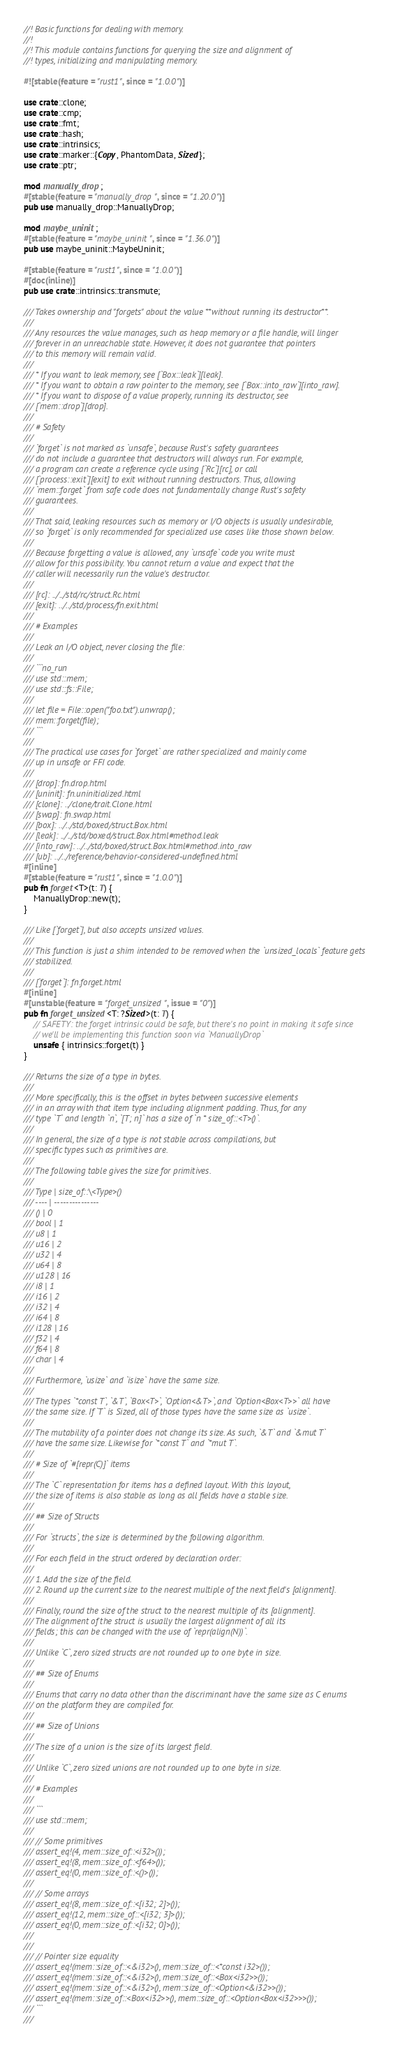Convert code to text. <code><loc_0><loc_0><loc_500><loc_500><_Rust_>//! Basic functions for dealing with memory.
//!
//! This module contains functions for querying the size and alignment of
//! types, initializing and manipulating memory.

#![stable(feature = "rust1", since = "1.0.0")]

use crate::clone;
use crate::cmp;
use crate::fmt;
use crate::hash;
use crate::intrinsics;
use crate::marker::{Copy, PhantomData, Sized};
use crate::ptr;

mod manually_drop;
#[stable(feature = "manually_drop", since = "1.20.0")]
pub use manually_drop::ManuallyDrop;

mod maybe_uninit;
#[stable(feature = "maybe_uninit", since = "1.36.0")]
pub use maybe_uninit::MaybeUninit;

#[stable(feature = "rust1", since = "1.0.0")]
#[doc(inline)]
pub use crate::intrinsics::transmute;

/// Takes ownership and "forgets" about the value **without running its destructor**.
///
/// Any resources the value manages, such as heap memory or a file handle, will linger
/// forever in an unreachable state. However, it does not guarantee that pointers
/// to this memory will remain valid.
///
/// * If you want to leak memory, see [`Box::leak`][leak].
/// * If you want to obtain a raw pointer to the memory, see [`Box::into_raw`][into_raw].
/// * If you want to dispose of a value properly, running its destructor, see
/// [`mem::drop`][drop].
///
/// # Safety
///
/// `forget` is not marked as `unsafe`, because Rust's safety guarantees
/// do not include a guarantee that destructors will always run. For example,
/// a program can create a reference cycle using [`Rc`][rc], or call
/// [`process::exit`][exit] to exit without running destructors. Thus, allowing
/// `mem::forget` from safe code does not fundamentally change Rust's safety
/// guarantees.
///
/// That said, leaking resources such as memory or I/O objects is usually undesirable,
/// so `forget` is only recommended for specialized use cases like those shown below.
///
/// Because forgetting a value is allowed, any `unsafe` code you write must
/// allow for this possibility. You cannot return a value and expect that the
/// caller will necessarily run the value's destructor.
///
/// [rc]: ../../std/rc/struct.Rc.html
/// [exit]: ../../std/process/fn.exit.html
///
/// # Examples
///
/// Leak an I/O object, never closing the file:
///
/// ```no_run
/// use std::mem;
/// use std::fs::File;
///
/// let file = File::open("foo.txt").unwrap();
/// mem::forget(file);
/// ```
///
/// The practical use cases for `forget` are rather specialized and mainly come
/// up in unsafe or FFI code.
///
/// [drop]: fn.drop.html
/// [uninit]: fn.uninitialized.html
/// [clone]: ../clone/trait.Clone.html
/// [swap]: fn.swap.html
/// [box]: ../../std/boxed/struct.Box.html
/// [leak]: ../../std/boxed/struct.Box.html#method.leak
/// [into_raw]: ../../std/boxed/struct.Box.html#method.into_raw
/// [ub]: ../../reference/behavior-considered-undefined.html
#[inline]
#[stable(feature = "rust1", since = "1.0.0")]
pub fn forget<T>(t: T) {
    ManuallyDrop::new(t);
}

/// Like [`forget`], but also accepts unsized values.
///
/// This function is just a shim intended to be removed when the `unsized_locals` feature gets
/// stabilized.
///
/// [`forget`]: fn.forget.html
#[inline]
#[unstable(feature = "forget_unsized", issue = "0")]
pub fn forget_unsized<T: ?Sized>(t: T) {
    // SAFETY: the forget intrinsic could be safe, but there's no point in making it safe since
    // we'll be implementing this function soon via `ManuallyDrop`
    unsafe { intrinsics::forget(t) }
}

/// Returns the size of a type in bytes.
///
/// More specifically, this is the offset in bytes between successive elements
/// in an array with that item type including alignment padding. Thus, for any
/// type `T` and length `n`, `[T; n]` has a size of `n * size_of::<T>()`.
///
/// In general, the size of a type is not stable across compilations, but
/// specific types such as primitives are.
///
/// The following table gives the size for primitives.
///
/// Type | size_of::\<Type>()
/// ---- | ---------------
/// () | 0
/// bool | 1
/// u8 | 1
/// u16 | 2
/// u32 | 4
/// u64 | 8
/// u128 | 16
/// i8 | 1
/// i16 | 2
/// i32 | 4
/// i64 | 8
/// i128 | 16
/// f32 | 4
/// f64 | 8
/// char | 4
///
/// Furthermore, `usize` and `isize` have the same size.
///
/// The types `*const T`, `&T`, `Box<T>`, `Option<&T>`, and `Option<Box<T>>` all have
/// the same size. If `T` is Sized, all of those types have the same size as `usize`.
///
/// The mutability of a pointer does not change its size. As such, `&T` and `&mut T`
/// have the same size. Likewise for `*const T` and `*mut T`.
///
/// # Size of `#[repr(C)]` items
///
/// The `C` representation for items has a defined layout. With this layout,
/// the size of items is also stable as long as all fields have a stable size.
///
/// ## Size of Structs
///
/// For `structs`, the size is determined by the following algorithm.
///
/// For each field in the struct ordered by declaration order:
///
/// 1. Add the size of the field.
/// 2. Round up the current size to the nearest multiple of the next field's [alignment].
///
/// Finally, round the size of the struct to the nearest multiple of its [alignment].
/// The alignment of the struct is usually the largest alignment of all its
/// fields; this can be changed with the use of `repr(align(N))`.
///
/// Unlike `C`, zero sized structs are not rounded up to one byte in size.
///
/// ## Size of Enums
///
/// Enums that carry no data other than the discriminant have the same size as C enums
/// on the platform they are compiled for.
///
/// ## Size of Unions
///
/// The size of a union is the size of its largest field.
///
/// Unlike `C`, zero sized unions are not rounded up to one byte in size.
///
/// # Examples
///
/// ```
/// use std::mem;
///
/// // Some primitives
/// assert_eq!(4, mem::size_of::<i32>());
/// assert_eq!(8, mem::size_of::<f64>());
/// assert_eq!(0, mem::size_of::<()>());
///
/// // Some arrays
/// assert_eq!(8, mem::size_of::<[i32; 2]>());
/// assert_eq!(12, mem::size_of::<[i32; 3]>());
/// assert_eq!(0, mem::size_of::<[i32; 0]>());
///
///
/// // Pointer size equality
/// assert_eq!(mem::size_of::<&i32>(), mem::size_of::<*const i32>());
/// assert_eq!(mem::size_of::<&i32>(), mem::size_of::<Box<i32>>());
/// assert_eq!(mem::size_of::<&i32>(), mem::size_of::<Option<&i32>>());
/// assert_eq!(mem::size_of::<Box<i32>>(), mem::size_of::<Option<Box<i32>>>());
/// ```
///</code> 